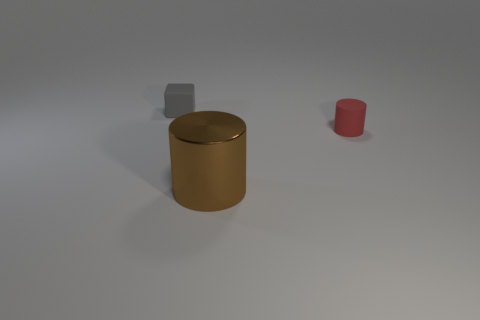Add 1 small purple matte cubes. How many objects exist? 4 Subtract all cylinders. How many objects are left? 1 Subtract 0 red spheres. How many objects are left? 3 Subtract all green rubber blocks. Subtract all rubber blocks. How many objects are left? 2 Add 3 small cylinders. How many small cylinders are left? 4 Add 3 brown cylinders. How many brown cylinders exist? 4 